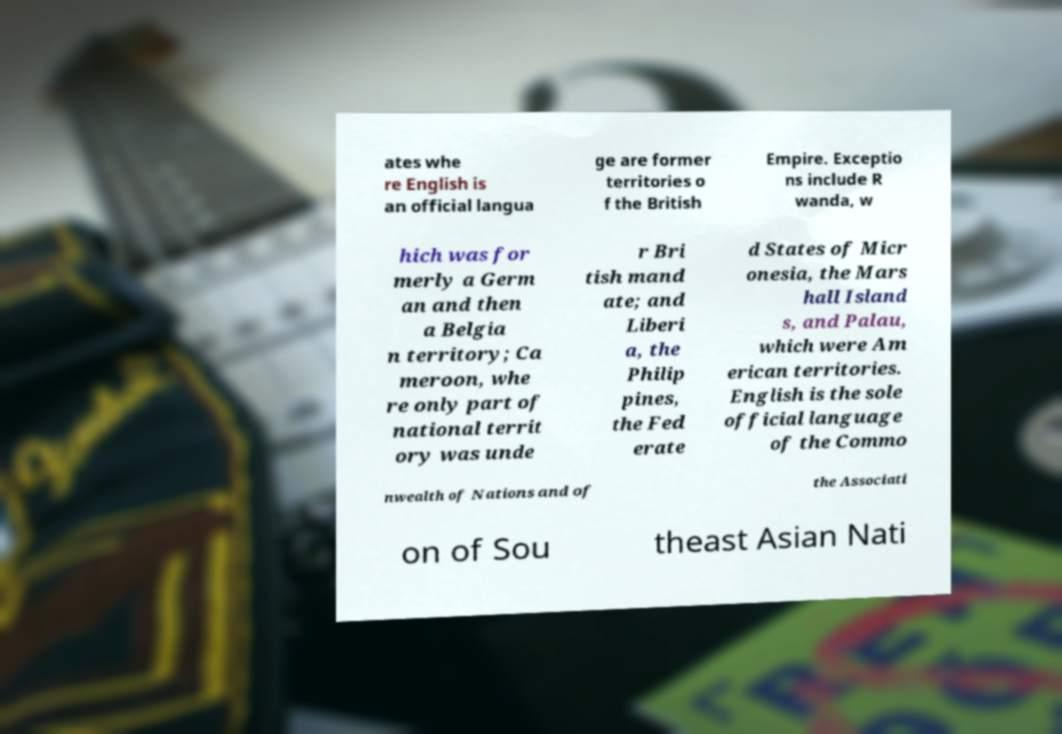For documentation purposes, I need the text within this image transcribed. Could you provide that? ates whe re English is an official langua ge are former territories o f the British Empire. Exceptio ns include R wanda, w hich was for merly a Germ an and then a Belgia n territory; Ca meroon, whe re only part of national territ ory was unde r Bri tish mand ate; and Liberi a, the Philip pines, the Fed erate d States of Micr onesia, the Mars hall Island s, and Palau, which were Am erican territories. English is the sole official language of the Commo nwealth of Nations and of the Associati on of Sou theast Asian Nati 